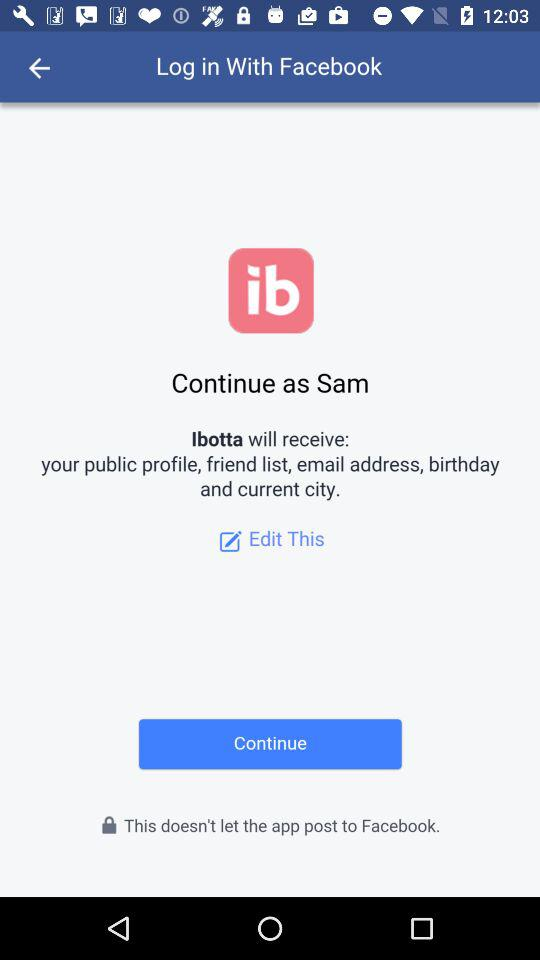What application can be used to log in? The application "Facebook" can be used to log in. 